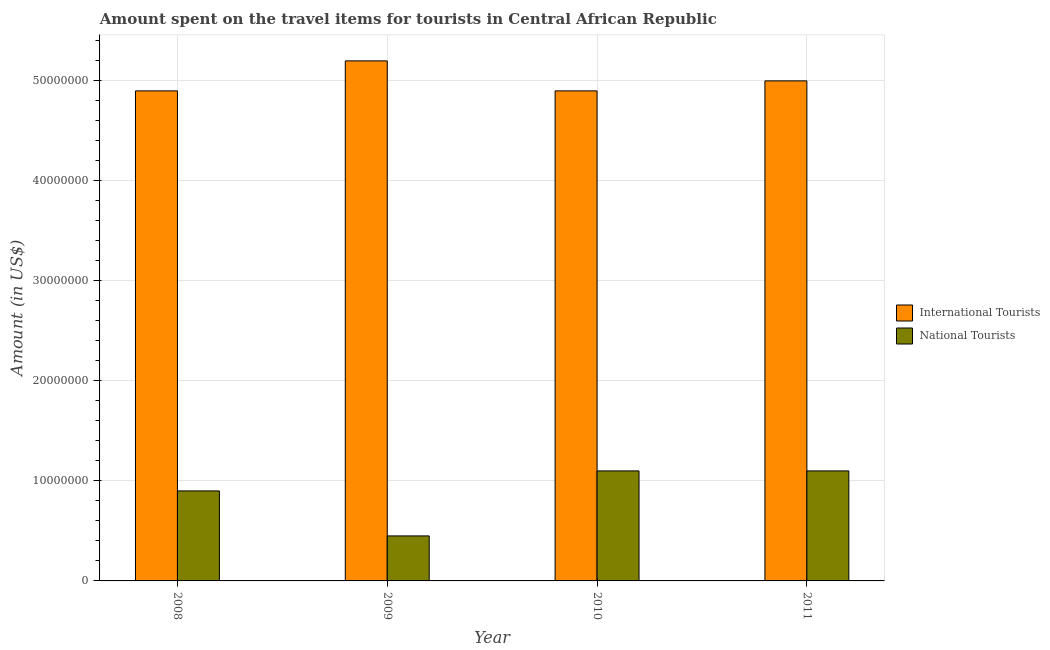How many bars are there on the 4th tick from the left?
Keep it short and to the point. 2. What is the label of the 3rd group of bars from the left?
Give a very brief answer. 2010. What is the amount spent on travel items of national tourists in 2008?
Provide a short and direct response. 9.00e+06. Across all years, what is the maximum amount spent on travel items of national tourists?
Provide a succinct answer. 1.10e+07. Across all years, what is the minimum amount spent on travel items of international tourists?
Offer a terse response. 4.90e+07. In which year was the amount spent on travel items of international tourists minimum?
Your response must be concise. 2008. What is the total amount spent on travel items of national tourists in the graph?
Offer a very short reply. 3.55e+07. What is the difference between the amount spent on travel items of national tourists in 2009 and that in 2011?
Your response must be concise. -6.50e+06. What is the difference between the amount spent on travel items of international tourists in 2011 and the amount spent on travel items of national tourists in 2009?
Provide a succinct answer. -2.00e+06. What is the average amount spent on travel items of international tourists per year?
Provide a short and direct response. 5.00e+07. In how many years, is the amount spent on travel items of national tourists greater than 16000000 US$?
Offer a very short reply. 0. What is the ratio of the amount spent on travel items of national tourists in 2008 to that in 2010?
Provide a short and direct response. 0.82. Is the amount spent on travel items of national tourists in 2008 less than that in 2009?
Your answer should be very brief. No. Is the difference between the amount spent on travel items of international tourists in 2008 and 2009 greater than the difference between the amount spent on travel items of national tourists in 2008 and 2009?
Your answer should be compact. No. What is the difference between the highest and the lowest amount spent on travel items of national tourists?
Ensure brevity in your answer.  6.50e+06. In how many years, is the amount spent on travel items of national tourists greater than the average amount spent on travel items of national tourists taken over all years?
Your response must be concise. 3. What does the 1st bar from the left in 2008 represents?
Keep it short and to the point. International Tourists. What does the 1st bar from the right in 2008 represents?
Ensure brevity in your answer.  National Tourists. Are all the bars in the graph horizontal?
Your response must be concise. No. How many years are there in the graph?
Ensure brevity in your answer.  4. What is the difference between two consecutive major ticks on the Y-axis?
Provide a short and direct response. 1.00e+07. What is the title of the graph?
Make the answer very short. Amount spent on the travel items for tourists in Central African Republic. What is the label or title of the X-axis?
Your answer should be very brief. Year. What is the Amount (in US$) in International Tourists in 2008?
Ensure brevity in your answer.  4.90e+07. What is the Amount (in US$) in National Tourists in 2008?
Your answer should be very brief. 9.00e+06. What is the Amount (in US$) in International Tourists in 2009?
Keep it short and to the point. 5.20e+07. What is the Amount (in US$) in National Tourists in 2009?
Provide a succinct answer. 4.50e+06. What is the Amount (in US$) in International Tourists in 2010?
Your answer should be very brief. 4.90e+07. What is the Amount (in US$) of National Tourists in 2010?
Make the answer very short. 1.10e+07. What is the Amount (in US$) in International Tourists in 2011?
Your answer should be very brief. 5.00e+07. What is the Amount (in US$) in National Tourists in 2011?
Your answer should be very brief. 1.10e+07. Across all years, what is the maximum Amount (in US$) in International Tourists?
Give a very brief answer. 5.20e+07. Across all years, what is the maximum Amount (in US$) in National Tourists?
Offer a very short reply. 1.10e+07. Across all years, what is the minimum Amount (in US$) of International Tourists?
Your answer should be very brief. 4.90e+07. Across all years, what is the minimum Amount (in US$) of National Tourists?
Provide a short and direct response. 4.50e+06. What is the total Amount (in US$) of National Tourists in the graph?
Your answer should be compact. 3.55e+07. What is the difference between the Amount (in US$) of National Tourists in 2008 and that in 2009?
Your answer should be very brief. 4.50e+06. What is the difference between the Amount (in US$) of International Tourists in 2008 and that in 2011?
Provide a succinct answer. -1.00e+06. What is the difference between the Amount (in US$) in National Tourists in 2009 and that in 2010?
Make the answer very short. -6.50e+06. What is the difference between the Amount (in US$) in National Tourists in 2009 and that in 2011?
Offer a terse response. -6.50e+06. What is the difference between the Amount (in US$) in International Tourists in 2010 and that in 2011?
Provide a short and direct response. -1.00e+06. What is the difference between the Amount (in US$) of International Tourists in 2008 and the Amount (in US$) of National Tourists in 2009?
Provide a short and direct response. 4.45e+07. What is the difference between the Amount (in US$) in International Tourists in 2008 and the Amount (in US$) in National Tourists in 2010?
Make the answer very short. 3.80e+07. What is the difference between the Amount (in US$) of International Tourists in 2008 and the Amount (in US$) of National Tourists in 2011?
Provide a succinct answer. 3.80e+07. What is the difference between the Amount (in US$) of International Tourists in 2009 and the Amount (in US$) of National Tourists in 2010?
Offer a terse response. 4.10e+07. What is the difference between the Amount (in US$) of International Tourists in 2009 and the Amount (in US$) of National Tourists in 2011?
Ensure brevity in your answer.  4.10e+07. What is the difference between the Amount (in US$) in International Tourists in 2010 and the Amount (in US$) in National Tourists in 2011?
Keep it short and to the point. 3.80e+07. What is the average Amount (in US$) of International Tourists per year?
Your answer should be compact. 5.00e+07. What is the average Amount (in US$) of National Tourists per year?
Offer a very short reply. 8.88e+06. In the year 2008, what is the difference between the Amount (in US$) in International Tourists and Amount (in US$) in National Tourists?
Provide a short and direct response. 4.00e+07. In the year 2009, what is the difference between the Amount (in US$) of International Tourists and Amount (in US$) of National Tourists?
Ensure brevity in your answer.  4.75e+07. In the year 2010, what is the difference between the Amount (in US$) of International Tourists and Amount (in US$) of National Tourists?
Provide a succinct answer. 3.80e+07. In the year 2011, what is the difference between the Amount (in US$) of International Tourists and Amount (in US$) of National Tourists?
Offer a terse response. 3.90e+07. What is the ratio of the Amount (in US$) of International Tourists in 2008 to that in 2009?
Provide a short and direct response. 0.94. What is the ratio of the Amount (in US$) of National Tourists in 2008 to that in 2010?
Ensure brevity in your answer.  0.82. What is the ratio of the Amount (in US$) in International Tourists in 2008 to that in 2011?
Keep it short and to the point. 0.98. What is the ratio of the Amount (in US$) of National Tourists in 2008 to that in 2011?
Provide a succinct answer. 0.82. What is the ratio of the Amount (in US$) of International Tourists in 2009 to that in 2010?
Make the answer very short. 1.06. What is the ratio of the Amount (in US$) in National Tourists in 2009 to that in 2010?
Ensure brevity in your answer.  0.41. What is the ratio of the Amount (in US$) of International Tourists in 2009 to that in 2011?
Keep it short and to the point. 1.04. What is the ratio of the Amount (in US$) of National Tourists in 2009 to that in 2011?
Make the answer very short. 0.41. What is the ratio of the Amount (in US$) of International Tourists in 2010 to that in 2011?
Give a very brief answer. 0.98. What is the ratio of the Amount (in US$) of National Tourists in 2010 to that in 2011?
Your response must be concise. 1. What is the difference between the highest and the second highest Amount (in US$) in National Tourists?
Provide a short and direct response. 0. What is the difference between the highest and the lowest Amount (in US$) in International Tourists?
Make the answer very short. 3.00e+06. What is the difference between the highest and the lowest Amount (in US$) in National Tourists?
Offer a terse response. 6.50e+06. 